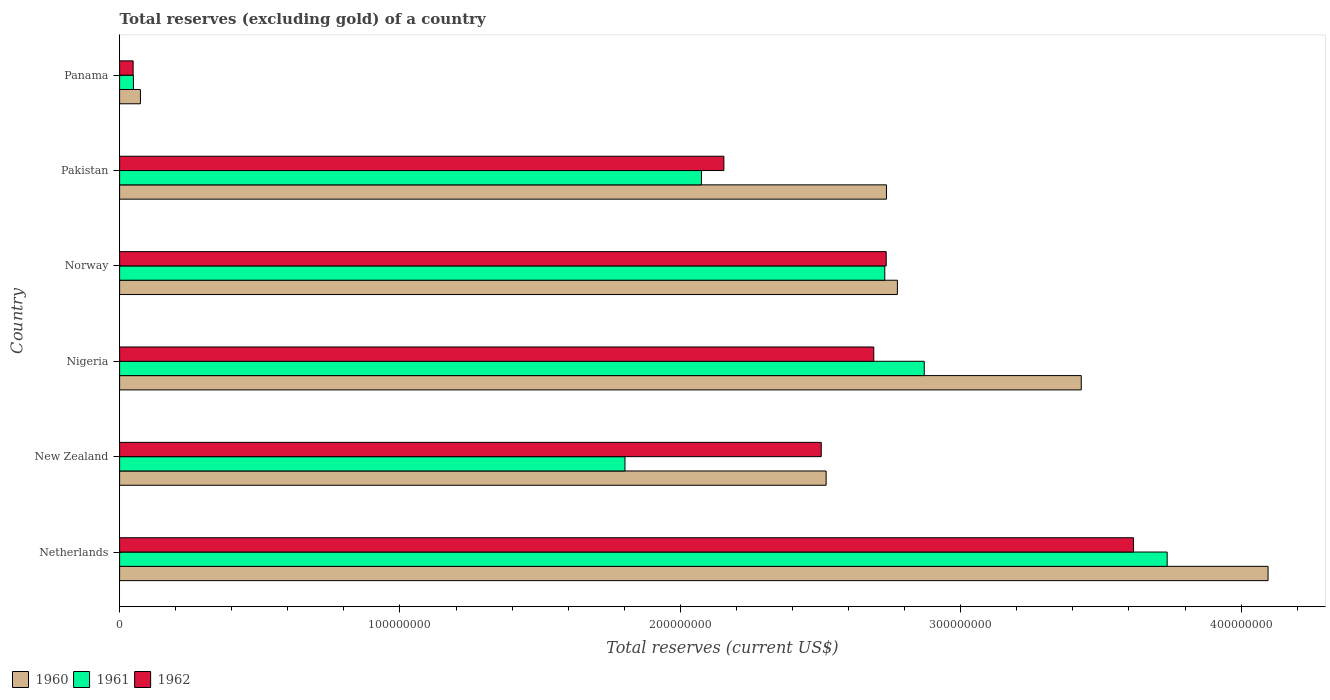How many bars are there on the 1st tick from the top?
Your answer should be very brief. 3. How many bars are there on the 6th tick from the bottom?
Make the answer very short. 3. What is the label of the 5th group of bars from the top?
Keep it short and to the point. New Zealand. What is the total reserves (excluding gold) in 1961 in New Zealand?
Your answer should be compact. 1.80e+08. Across all countries, what is the maximum total reserves (excluding gold) in 1960?
Provide a short and direct response. 4.10e+08. Across all countries, what is the minimum total reserves (excluding gold) in 1962?
Make the answer very short. 4.83e+06. In which country was the total reserves (excluding gold) in 1962 maximum?
Provide a succinct answer. Netherlands. In which country was the total reserves (excluding gold) in 1962 minimum?
Give a very brief answer. Panama. What is the total total reserves (excluding gold) in 1961 in the graph?
Ensure brevity in your answer.  1.33e+09. What is the difference between the total reserves (excluding gold) in 1960 in Nigeria and that in Panama?
Provide a succinct answer. 3.36e+08. What is the difference between the total reserves (excluding gold) in 1961 in Norway and the total reserves (excluding gold) in 1962 in Nigeria?
Offer a terse response. 3.92e+06. What is the average total reserves (excluding gold) in 1962 per country?
Provide a short and direct response. 2.29e+08. What is the difference between the total reserves (excluding gold) in 1962 and total reserves (excluding gold) in 1961 in New Zealand?
Ensure brevity in your answer.  7.00e+07. In how many countries, is the total reserves (excluding gold) in 1961 greater than 400000000 US$?
Your answer should be compact. 0. What is the ratio of the total reserves (excluding gold) in 1960 in Nigeria to that in Norway?
Keep it short and to the point. 1.24. What is the difference between the highest and the second highest total reserves (excluding gold) in 1960?
Ensure brevity in your answer.  6.66e+07. What is the difference between the highest and the lowest total reserves (excluding gold) in 1961?
Your answer should be very brief. 3.69e+08. In how many countries, is the total reserves (excluding gold) in 1961 greater than the average total reserves (excluding gold) in 1961 taken over all countries?
Provide a succinct answer. 3. Is it the case that in every country, the sum of the total reserves (excluding gold) in 1961 and total reserves (excluding gold) in 1960 is greater than the total reserves (excluding gold) in 1962?
Your response must be concise. Yes. Are all the bars in the graph horizontal?
Offer a very short reply. Yes. How many countries are there in the graph?
Make the answer very short. 6. What is the difference between two consecutive major ticks on the X-axis?
Give a very brief answer. 1.00e+08. Are the values on the major ticks of X-axis written in scientific E-notation?
Your response must be concise. No. Does the graph contain any zero values?
Keep it short and to the point. No. Does the graph contain grids?
Your answer should be very brief. No. How many legend labels are there?
Provide a succinct answer. 3. How are the legend labels stacked?
Your answer should be compact. Horizontal. What is the title of the graph?
Give a very brief answer. Total reserves (excluding gold) of a country. What is the label or title of the X-axis?
Your answer should be very brief. Total reserves (current US$). What is the Total reserves (current US$) in 1960 in Netherlands?
Provide a short and direct response. 4.10e+08. What is the Total reserves (current US$) in 1961 in Netherlands?
Ensure brevity in your answer.  3.74e+08. What is the Total reserves (current US$) of 1962 in Netherlands?
Your response must be concise. 3.62e+08. What is the Total reserves (current US$) of 1960 in New Zealand?
Offer a terse response. 2.52e+08. What is the Total reserves (current US$) in 1961 in New Zealand?
Offer a very short reply. 1.80e+08. What is the Total reserves (current US$) of 1962 in New Zealand?
Give a very brief answer. 2.50e+08. What is the Total reserves (current US$) of 1960 in Nigeria?
Provide a short and direct response. 3.43e+08. What is the Total reserves (current US$) in 1961 in Nigeria?
Your response must be concise. 2.87e+08. What is the Total reserves (current US$) of 1962 in Nigeria?
Make the answer very short. 2.69e+08. What is the Total reserves (current US$) in 1960 in Norway?
Ensure brevity in your answer.  2.77e+08. What is the Total reserves (current US$) of 1961 in Norway?
Provide a succinct answer. 2.73e+08. What is the Total reserves (current US$) of 1962 in Norway?
Offer a very short reply. 2.73e+08. What is the Total reserves (current US$) of 1960 in Pakistan?
Your answer should be compact. 2.74e+08. What is the Total reserves (current US$) of 1961 in Pakistan?
Make the answer very short. 2.08e+08. What is the Total reserves (current US$) of 1962 in Pakistan?
Keep it short and to the point. 2.16e+08. What is the Total reserves (current US$) of 1960 in Panama?
Your answer should be very brief. 7.43e+06. What is the Total reserves (current US$) of 1961 in Panama?
Offer a very short reply. 4.93e+06. What is the Total reserves (current US$) of 1962 in Panama?
Make the answer very short. 4.83e+06. Across all countries, what is the maximum Total reserves (current US$) in 1960?
Your answer should be compact. 4.10e+08. Across all countries, what is the maximum Total reserves (current US$) in 1961?
Your response must be concise. 3.74e+08. Across all countries, what is the maximum Total reserves (current US$) in 1962?
Your answer should be very brief. 3.62e+08. Across all countries, what is the minimum Total reserves (current US$) in 1960?
Your response must be concise. 7.43e+06. Across all countries, what is the minimum Total reserves (current US$) in 1961?
Offer a very short reply. 4.93e+06. Across all countries, what is the minimum Total reserves (current US$) of 1962?
Provide a succinct answer. 4.83e+06. What is the total Total reserves (current US$) of 1960 in the graph?
Provide a succinct answer. 1.56e+09. What is the total Total reserves (current US$) in 1961 in the graph?
Your answer should be very brief. 1.33e+09. What is the total Total reserves (current US$) in 1962 in the graph?
Give a very brief answer. 1.37e+09. What is the difference between the Total reserves (current US$) in 1960 in Netherlands and that in New Zealand?
Give a very brief answer. 1.58e+08. What is the difference between the Total reserves (current US$) in 1961 in Netherlands and that in New Zealand?
Ensure brevity in your answer.  1.93e+08. What is the difference between the Total reserves (current US$) of 1962 in Netherlands and that in New Zealand?
Give a very brief answer. 1.11e+08. What is the difference between the Total reserves (current US$) in 1960 in Netherlands and that in Nigeria?
Make the answer very short. 6.66e+07. What is the difference between the Total reserves (current US$) of 1961 in Netherlands and that in Nigeria?
Keep it short and to the point. 8.66e+07. What is the difference between the Total reserves (current US$) in 1962 in Netherlands and that in Nigeria?
Provide a succinct answer. 9.26e+07. What is the difference between the Total reserves (current US$) in 1960 in Netherlands and that in Norway?
Provide a short and direct response. 1.32e+08. What is the difference between the Total reserves (current US$) of 1961 in Netherlands and that in Norway?
Keep it short and to the point. 1.01e+08. What is the difference between the Total reserves (current US$) in 1962 in Netherlands and that in Norway?
Give a very brief answer. 8.82e+07. What is the difference between the Total reserves (current US$) in 1960 in Netherlands and that in Pakistan?
Give a very brief answer. 1.36e+08. What is the difference between the Total reserves (current US$) of 1961 in Netherlands and that in Pakistan?
Make the answer very short. 1.66e+08. What is the difference between the Total reserves (current US$) of 1962 in Netherlands and that in Pakistan?
Ensure brevity in your answer.  1.46e+08. What is the difference between the Total reserves (current US$) of 1960 in Netherlands and that in Panama?
Provide a succinct answer. 4.02e+08. What is the difference between the Total reserves (current US$) in 1961 in Netherlands and that in Panama?
Keep it short and to the point. 3.69e+08. What is the difference between the Total reserves (current US$) in 1962 in Netherlands and that in Panama?
Provide a succinct answer. 3.57e+08. What is the difference between the Total reserves (current US$) in 1960 in New Zealand and that in Nigeria?
Offer a very short reply. -9.10e+07. What is the difference between the Total reserves (current US$) of 1961 in New Zealand and that in Nigeria?
Provide a succinct answer. -1.07e+08. What is the difference between the Total reserves (current US$) in 1962 in New Zealand and that in Nigeria?
Give a very brief answer. -1.87e+07. What is the difference between the Total reserves (current US$) in 1960 in New Zealand and that in Norway?
Ensure brevity in your answer.  -2.54e+07. What is the difference between the Total reserves (current US$) of 1961 in New Zealand and that in Norway?
Ensure brevity in your answer.  -9.27e+07. What is the difference between the Total reserves (current US$) of 1962 in New Zealand and that in Norway?
Provide a succinct answer. -2.32e+07. What is the difference between the Total reserves (current US$) of 1960 in New Zealand and that in Pakistan?
Your answer should be very brief. -2.15e+07. What is the difference between the Total reserves (current US$) in 1961 in New Zealand and that in Pakistan?
Give a very brief answer. -2.73e+07. What is the difference between the Total reserves (current US$) in 1962 in New Zealand and that in Pakistan?
Your response must be concise. 3.47e+07. What is the difference between the Total reserves (current US$) in 1960 in New Zealand and that in Panama?
Offer a terse response. 2.45e+08. What is the difference between the Total reserves (current US$) in 1961 in New Zealand and that in Panama?
Keep it short and to the point. 1.75e+08. What is the difference between the Total reserves (current US$) of 1962 in New Zealand and that in Panama?
Ensure brevity in your answer.  2.45e+08. What is the difference between the Total reserves (current US$) in 1960 in Nigeria and that in Norway?
Your answer should be very brief. 6.56e+07. What is the difference between the Total reserves (current US$) in 1961 in Nigeria and that in Norway?
Make the answer very short. 1.41e+07. What is the difference between the Total reserves (current US$) in 1962 in Nigeria and that in Norway?
Your response must be concise. -4.43e+06. What is the difference between the Total reserves (current US$) of 1960 in Nigeria and that in Pakistan?
Ensure brevity in your answer.  6.95e+07. What is the difference between the Total reserves (current US$) in 1961 in Nigeria and that in Pakistan?
Ensure brevity in your answer.  7.95e+07. What is the difference between the Total reserves (current US$) of 1962 in Nigeria and that in Pakistan?
Provide a succinct answer. 5.35e+07. What is the difference between the Total reserves (current US$) of 1960 in Nigeria and that in Panama?
Your response must be concise. 3.36e+08. What is the difference between the Total reserves (current US$) of 1961 in Nigeria and that in Panama?
Make the answer very short. 2.82e+08. What is the difference between the Total reserves (current US$) of 1962 in Nigeria and that in Panama?
Provide a short and direct response. 2.64e+08. What is the difference between the Total reserves (current US$) in 1960 in Norway and that in Pakistan?
Provide a succinct answer. 3.90e+06. What is the difference between the Total reserves (current US$) of 1961 in Norway and that in Pakistan?
Ensure brevity in your answer.  6.54e+07. What is the difference between the Total reserves (current US$) in 1962 in Norway and that in Pakistan?
Ensure brevity in your answer.  5.79e+07. What is the difference between the Total reserves (current US$) in 1960 in Norway and that in Panama?
Your answer should be very brief. 2.70e+08. What is the difference between the Total reserves (current US$) in 1961 in Norway and that in Panama?
Provide a succinct answer. 2.68e+08. What is the difference between the Total reserves (current US$) of 1962 in Norway and that in Panama?
Provide a succinct answer. 2.69e+08. What is the difference between the Total reserves (current US$) of 1960 in Pakistan and that in Panama?
Make the answer very short. 2.66e+08. What is the difference between the Total reserves (current US$) of 1961 in Pakistan and that in Panama?
Your answer should be very brief. 2.03e+08. What is the difference between the Total reserves (current US$) of 1962 in Pakistan and that in Panama?
Your answer should be compact. 2.11e+08. What is the difference between the Total reserves (current US$) of 1960 in Netherlands and the Total reserves (current US$) of 1961 in New Zealand?
Provide a short and direct response. 2.29e+08. What is the difference between the Total reserves (current US$) in 1960 in Netherlands and the Total reserves (current US$) in 1962 in New Zealand?
Provide a succinct answer. 1.59e+08. What is the difference between the Total reserves (current US$) in 1961 in Netherlands and the Total reserves (current US$) in 1962 in New Zealand?
Your response must be concise. 1.23e+08. What is the difference between the Total reserves (current US$) of 1960 in Netherlands and the Total reserves (current US$) of 1961 in Nigeria?
Your answer should be compact. 1.23e+08. What is the difference between the Total reserves (current US$) of 1960 in Netherlands and the Total reserves (current US$) of 1962 in Nigeria?
Give a very brief answer. 1.41e+08. What is the difference between the Total reserves (current US$) of 1961 in Netherlands and the Total reserves (current US$) of 1962 in Nigeria?
Your response must be concise. 1.05e+08. What is the difference between the Total reserves (current US$) in 1960 in Netherlands and the Total reserves (current US$) in 1961 in Norway?
Offer a terse response. 1.37e+08. What is the difference between the Total reserves (current US$) of 1960 in Netherlands and the Total reserves (current US$) of 1962 in Norway?
Provide a succinct answer. 1.36e+08. What is the difference between the Total reserves (current US$) of 1961 in Netherlands and the Total reserves (current US$) of 1962 in Norway?
Provide a succinct answer. 1.00e+08. What is the difference between the Total reserves (current US$) of 1960 in Netherlands and the Total reserves (current US$) of 1961 in Pakistan?
Make the answer very short. 2.02e+08. What is the difference between the Total reserves (current US$) of 1960 in Netherlands and the Total reserves (current US$) of 1962 in Pakistan?
Ensure brevity in your answer.  1.94e+08. What is the difference between the Total reserves (current US$) in 1961 in Netherlands and the Total reserves (current US$) in 1962 in Pakistan?
Ensure brevity in your answer.  1.58e+08. What is the difference between the Total reserves (current US$) in 1960 in Netherlands and the Total reserves (current US$) in 1961 in Panama?
Give a very brief answer. 4.05e+08. What is the difference between the Total reserves (current US$) in 1960 in Netherlands and the Total reserves (current US$) in 1962 in Panama?
Offer a very short reply. 4.05e+08. What is the difference between the Total reserves (current US$) of 1961 in Netherlands and the Total reserves (current US$) of 1962 in Panama?
Your answer should be compact. 3.69e+08. What is the difference between the Total reserves (current US$) in 1960 in New Zealand and the Total reserves (current US$) in 1961 in Nigeria?
Ensure brevity in your answer.  -3.50e+07. What is the difference between the Total reserves (current US$) of 1960 in New Zealand and the Total reserves (current US$) of 1962 in Nigeria?
Offer a very short reply. -1.70e+07. What is the difference between the Total reserves (current US$) of 1961 in New Zealand and the Total reserves (current US$) of 1962 in Nigeria?
Your answer should be very brief. -8.88e+07. What is the difference between the Total reserves (current US$) in 1960 in New Zealand and the Total reserves (current US$) in 1961 in Norway?
Keep it short and to the point. -2.09e+07. What is the difference between the Total reserves (current US$) of 1960 in New Zealand and the Total reserves (current US$) of 1962 in Norway?
Make the answer very short. -2.14e+07. What is the difference between the Total reserves (current US$) of 1961 in New Zealand and the Total reserves (current US$) of 1962 in Norway?
Keep it short and to the point. -9.32e+07. What is the difference between the Total reserves (current US$) of 1960 in New Zealand and the Total reserves (current US$) of 1961 in Pakistan?
Provide a succinct answer. 4.45e+07. What is the difference between the Total reserves (current US$) of 1960 in New Zealand and the Total reserves (current US$) of 1962 in Pakistan?
Give a very brief answer. 3.65e+07. What is the difference between the Total reserves (current US$) in 1961 in New Zealand and the Total reserves (current US$) in 1962 in Pakistan?
Offer a terse response. -3.53e+07. What is the difference between the Total reserves (current US$) of 1960 in New Zealand and the Total reserves (current US$) of 1961 in Panama?
Your answer should be very brief. 2.47e+08. What is the difference between the Total reserves (current US$) of 1960 in New Zealand and the Total reserves (current US$) of 1962 in Panama?
Ensure brevity in your answer.  2.47e+08. What is the difference between the Total reserves (current US$) in 1961 in New Zealand and the Total reserves (current US$) in 1962 in Panama?
Offer a very short reply. 1.75e+08. What is the difference between the Total reserves (current US$) in 1960 in Nigeria and the Total reserves (current US$) in 1961 in Norway?
Offer a very short reply. 7.01e+07. What is the difference between the Total reserves (current US$) of 1960 in Nigeria and the Total reserves (current US$) of 1962 in Norway?
Offer a terse response. 6.96e+07. What is the difference between the Total reserves (current US$) in 1961 in Nigeria and the Total reserves (current US$) in 1962 in Norway?
Provide a succinct answer. 1.36e+07. What is the difference between the Total reserves (current US$) in 1960 in Nigeria and the Total reserves (current US$) in 1961 in Pakistan?
Offer a terse response. 1.35e+08. What is the difference between the Total reserves (current US$) of 1960 in Nigeria and the Total reserves (current US$) of 1962 in Pakistan?
Provide a succinct answer. 1.27e+08. What is the difference between the Total reserves (current US$) in 1961 in Nigeria and the Total reserves (current US$) in 1962 in Pakistan?
Your answer should be compact. 7.15e+07. What is the difference between the Total reserves (current US$) in 1960 in Nigeria and the Total reserves (current US$) in 1961 in Panama?
Provide a succinct answer. 3.38e+08. What is the difference between the Total reserves (current US$) of 1960 in Nigeria and the Total reserves (current US$) of 1962 in Panama?
Ensure brevity in your answer.  3.38e+08. What is the difference between the Total reserves (current US$) of 1961 in Nigeria and the Total reserves (current US$) of 1962 in Panama?
Offer a very short reply. 2.82e+08. What is the difference between the Total reserves (current US$) of 1960 in Norway and the Total reserves (current US$) of 1961 in Pakistan?
Your answer should be compact. 6.99e+07. What is the difference between the Total reserves (current US$) of 1960 in Norway and the Total reserves (current US$) of 1962 in Pakistan?
Provide a succinct answer. 6.19e+07. What is the difference between the Total reserves (current US$) in 1961 in Norway and the Total reserves (current US$) in 1962 in Pakistan?
Offer a very short reply. 5.74e+07. What is the difference between the Total reserves (current US$) in 1960 in Norway and the Total reserves (current US$) in 1961 in Panama?
Make the answer very short. 2.72e+08. What is the difference between the Total reserves (current US$) of 1960 in Norway and the Total reserves (current US$) of 1962 in Panama?
Give a very brief answer. 2.73e+08. What is the difference between the Total reserves (current US$) in 1961 in Norway and the Total reserves (current US$) in 1962 in Panama?
Make the answer very short. 2.68e+08. What is the difference between the Total reserves (current US$) in 1960 in Pakistan and the Total reserves (current US$) in 1961 in Panama?
Your response must be concise. 2.69e+08. What is the difference between the Total reserves (current US$) of 1960 in Pakistan and the Total reserves (current US$) of 1962 in Panama?
Give a very brief answer. 2.69e+08. What is the difference between the Total reserves (current US$) in 1961 in Pakistan and the Total reserves (current US$) in 1962 in Panama?
Your answer should be compact. 2.03e+08. What is the average Total reserves (current US$) in 1960 per country?
Offer a very short reply. 2.60e+08. What is the average Total reserves (current US$) of 1961 per country?
Ensure brevity in your answer.  2.21e+08. What is the average Total reserves (current US$) in 1962 per country?
Keep it short and to the point. 2.29e+08. What is the difference between the Total reserves (current US$) of 1960 and Total reserves (current US$) of 1961 in Netherlands?
Your answer should be very brief. 3.60e+07. What is the difference between the Total reserves (current US$) of 1960 and Total reserves (current US$) of 1962 in Netherlands?
Offer a very short reply. 4.80e+07. What is the difference between the Total reserves (current US$) in 1961 and Total reserves (current US$) in 1962 in Netherlands?
Offer a terse response. 1.20e+07. What is the difference between the Total reserves (current US$) of 1960 and Total reserves (current US$) of 1961 in New Zealand?
Your answer should be compact. 7.18e+07. What is the difference between the Total reserves (current US$) of 1960 and Total reserves (current US$) of 1962 in New Zealand?
Provide a succinct answer. 1.74e+06. What is the difference between the Total reserves (current US$) in 1961 and Total reserves (current US$) in 1962 in New Zealand?
Your answer should be very brief. -7.00e+07. What is the difference between the Total reserves (current US$) in 1960 and Total reserves (current US$) in 1961 in Nigeria?
Your response must be concise. 5.60e+07. What is the difference between the Total reserves (current US$) of 1960 and Total reserves (current US$) of 1962 in Nigeria?
Ensure brevity in your answer.  7.40e+07. What is the difference between the Total reserves (current US$) in 1961 and Total reserves (current US$) in 1962 in Nigeria?
Offer a terse response. 1.80e+07. What is the difference between the Total reserves (current US$) of 1960 and Total reserves (current US$) of 1961 in Norway?
Make the answer very short. 4.50e+06. What is the difference between the Total reserves (current US$) in 1960 and Total reserves (current US$) in 1962 in Norway?
Give a very brief answer. 3.99e+06. What is the difference between the Total reserves (current US$) of 1961 and Total reserves (current US$) of 1962 in Norway?
Give a very brief answer. -5.10e+05. What is the difference between the Total reserves (current US$) in 1960 and Total reserves (current US$) in 1961 in Pakistan?
Keep it short and to the point. 6.60e+07. What is the difference between the Total reserves (current US$) of 1960 and Total reserves (current US$) of 1962 in Pakistan?
Your response must be concise. 5.80e+07. What is the difference between the Total reserves (current US$) of 1961 and Total reserves (current US$) of 1962 in Pakistan?
Your answer should be very brief. -8.00e+06. What is the difference between the Total reserves (current US$) of 1960 and Total reserves (current US$) of 1961 in Panama?
Keep it short and to the point. 2.50e+06. What is the difference between the Total reserves (current US$) of 1960 and Total reserves (current US$) of 1962 in Panama?
Keep it short and to the point. 2.60e+06. What is the ratio of the Total reserves (current US$) in 1960 in Netherlands to that in New Zealand?
Provide a succinct answer. 1.63. What is the ratio of the Total reserves (current US$) of 1961 in Netherlands to that in New Zealand?
Your answer should be compact. 2.07. What is the ratio of the Total reserves (current US$) in 1962 in Netherlands to that in New Zealand?
Offer a very short reply. 1.45. What is the ratio of the Total reserves (current US$) in 1960 in Netherlands to that in Nigeria?
Give a very brief answer. 1.19. What is the ratio of the Total reserves (current US$) of 1961 in Netherlands to that in Nigeria?
Give a very brief answer. 1.3. What is the ratio of the Total reserves (current US$) of 1962 in Netherlands to that in Nigeria?
Offer a terse response. 1.34. What is the ratio of the Total reserves (current US$) of 1960 in Netherlands to that in Norway?
Your response must be concise. 1.48. What is the ratio of the Total reserves (current US$) of 1961 in Netherlands to that in Norway?
Offer a terse response. 1.37. What is the ratio of the Total reserves (current US$) in 1962 in Netherlands to that in Norway?
Your answer should be very brief. 1.32. What is the ratio of the Total reserves (current US$) of 1960 in Netherlands to that in Pakistan?
Offer a very short reply. 1.5. What is the ratio of the Total reserves (current US$) in 1961 in Netherlands to that in Pakistan?
Your response must be concise. 1.8. What is the ratio of the Total reserves (current US$) of 1962 in Netherlands to that in Pakistan?
Your response must be concise. 1.68. What is the ratio of the Total reserves (current US$) of 1960 in Netherlands to that in Panama?
Make the answer very short. 55.13. What is the ratio of the Total reserves (current US$) in 1961 in Netherlands to that in Panama?
Ensure brevity in your answer.  75.79. What is the ratio of the Total reserves (current US$) in 1962 in Netherlands to that in Panama?
Your answer should be compact. 74.87. What is the ratio of the Total reserves (current US$) in 1960 in New Zealand to that in Nigeria?
Your response must be concise. 0.73. What is the ratio of the Total reserves (current US$) in 1961 in New Zealand to that in Nigeria?
Make the answer very short. 0.63. What is the ratio of the Total reserves (current US$) of 1962 in New Zealand to that in Nigeria?
Offer a terse response. 0.93. What is the ratio of the Total reserves (current US$) of 1960 in New Zealand to that in Norway?
Offer a very short reply. 0.91. What is the ratio of the Total reserves (current US$) of 1961 in New Zealand to that in Norway?
Keep it short and to the point. 0.66. What is the ratio of the Total reserves (current US$) in 1962 in New Zealand to that in Norway?
Keep it short and to the point. 0.92. What is the ratio of the Total reserves (current US$) in 1960 in New Zealand to that in Pakistan?
Offer a very short reply. 0.92. What is the ratio of the Total reserves (current US$) in 1961 in New Zealand to that in Pakistan?
Give a very brief answer. 0.87. What is the ratio of the Total reserves (current US$) of 1962 in New Zealand to that in Pakistan?
Give a very brief answer. 1.16. What is the ratio of the Total reserves (current US$) in 1960 in New Zealand to that in Panama?
Make the answer very short. 33.92. What is the ratio of the Total reserves (current US$) in 1961 in New Zealand to that in Panama?
Your answer should be compact. 36.56. What is the ratio of the Total reserves (current US$) of 1962 in New Zealand to that in Panama?
Make the answer very short. 51.81. What is the ratio of the Total reserves (current US$) of 1960 in Nigeria to that in Norway?
Give a very brief answer. 1.24. What is the ratio of the Total reserves (current US$) in 1961 in Nigeria to that in Norway?
Your answer should be very brief. 1.05. What is the ratio of the Total reserves (current US$) of 1962 in Nigeria to that in Norway?
Make the answer very short. 0.98. What is the ratio of the Total reserves (current US$) in 1960 in Nigeria to that in Pakistan?
Provide a succinct answer. 1.25. What is the ratio of the Total reserves (current US$) of 1961 in Nigeria to that in Pakistan?
Ensure brevity in your answer.  1.38. What is the ratio of the Total reserves (current US$) of 1962 in Nigeria to that in Pakistan?
Your response must be concise. 1.25. What is the ratio of the Total reserves (current US$) in 1960 in Nigeria to that in Panama?
Make the answer very short. 46.16. What is the ratio of the Total reserves (current US$) in 1961 in Nigeria to that in Panama?
Offer a very short reply. 58.22. What is the ratio of the Total reserves (current US$) of 1962 in Nigeria to that in Panama?
Provide a short and direct response. 55.69. What is the ratio of the Total reserves (current US$) of 1960 in Norway to that in Pakistan?
Keep it short and to the point. 1.01. What is the ratio of the Total reserves (current US$) in 1961 in Norway to that in Pakistan?
Provide a succinct answer. 1.32. What is the ratio of the Total reserves (current US$) in 1962 in Norway to that in Pakistan?
Your answer should be compact. 1.27. What is the ratio of the Total reserves (current US$) in 1960 in Norway to that in Panama?
Your answer should be very brief. 37.34. What is the ratio of the Total reserves (current US$) of 1961 in Norway to that in Panama?
Provide a short and direct response. 55.36. What is the ratio of the Total reserves (current US$) in 1962 in Norway to that in Panama?
Your answer should be compact. 56.61. What is the ratio of the Total reserves (current US$) of 1960 in Pakistan to that in Panama?
Offer a terse response. 36.81. What is the ratio of the Total reserves (current US$) in 1961 in Pakistan to that in Panama?
Give a very brief answer. 42.1. What is the ratio of the Total reserves (current US$) of 1962 in Pakistan to that in Panama?
Your answer should be very brief. 44.62. What is the difference between the highest and the second highest Total reserves (current US$) in 1960?
Offer a very short reply. 6.66e+07. What is the difference between the highest and the second highest Total reserves (current US$) in 1961?
Provide a short and direct response. 8.66e+07. What is the difference between the highest and the second highest Total reserves (current US$) in 1962?
Your answer should be compact. 8.82e+07. What is the difference between the highest and the lowest Total reserves (current US$) in 1960?
Offer a terse response. 4.02e+08. What is the difference between the highest and the lowest Total reserves (current US$) in 1961?
Make the answer very short. 3.69e+08. What is the difference between the highest and the lowest Total reserves (current US$) of 1962?
Ensure brevity in your answer.  3.57e+08. 